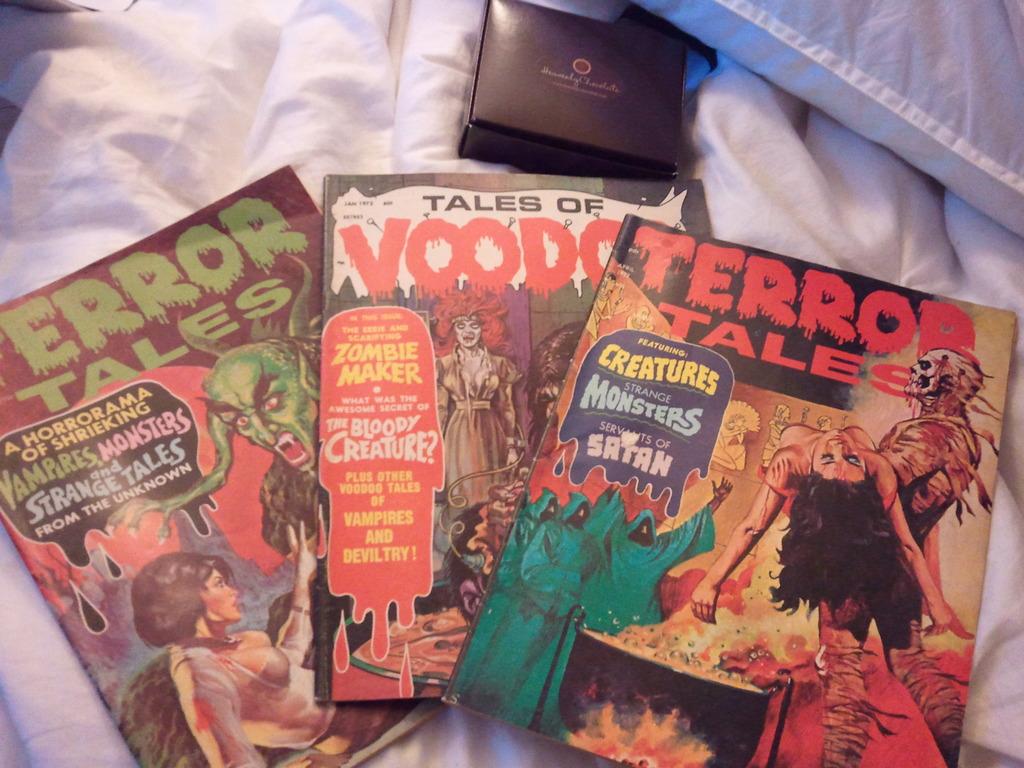What is the name of the book on the far right?
Give a very brief answer. Terror tales. What is the name of the book in the middle?
Your answer should be compact. Tales of voodoo. 